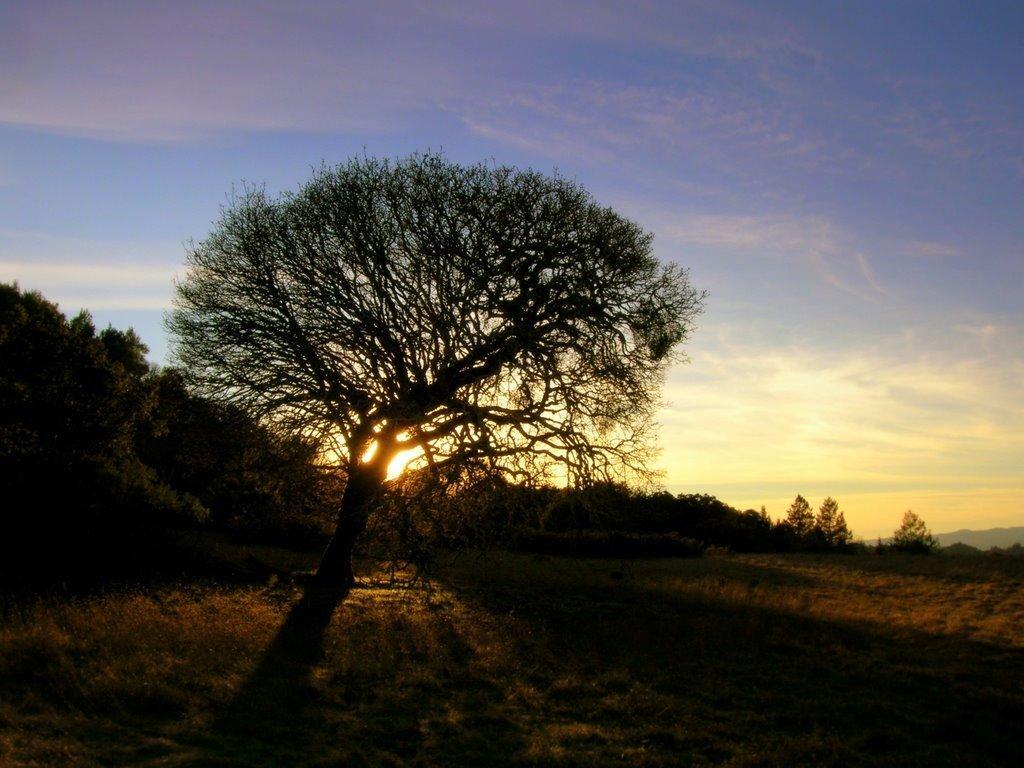How would you summarize this image in a sentence or two? On the left side, there is a tree on the ground on which there is grass. In the background, there are trees, mountains and there are clouds and a sun in the sky. 